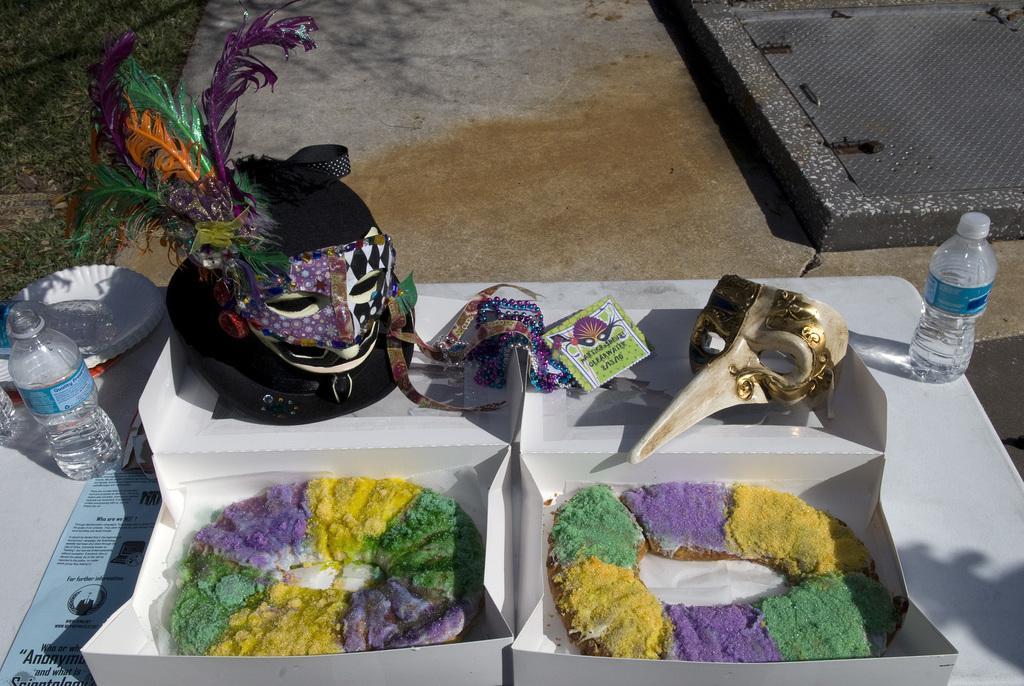Describe this image in one or two sentences. there are donuts in a white box. behind them there are masks. and at the right and left there are water bottles. 